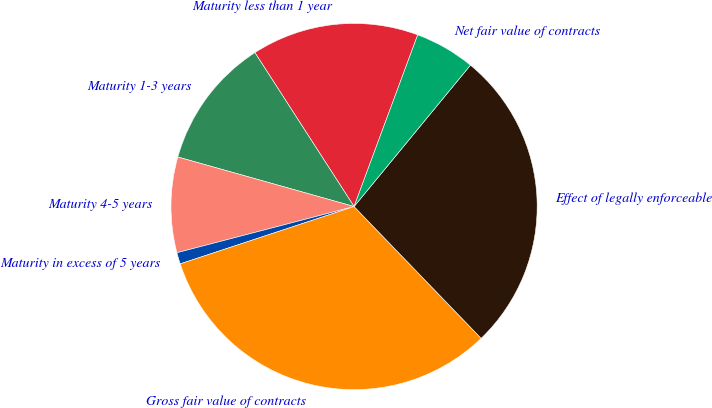<chart> <loc_0><loc_0><loc_500><loc_500><pie_chart><fcel>Maturity less than 1 year<fcel>Maturity 1-3 years<fcel>Maturity 4-5 years<fcel>Maturity in excess of 5 years<fcel>Gross fair value of contracts<fcel>Effect of legally enforceable<fcel>Net fair value of contracts<nl><fcel>14.76%<fcel>11.53%<fcel>8.42%<fcel>1.01%<fcel>32.14%<fcel>26.83%<fcel>5.31%<nl></chart> 